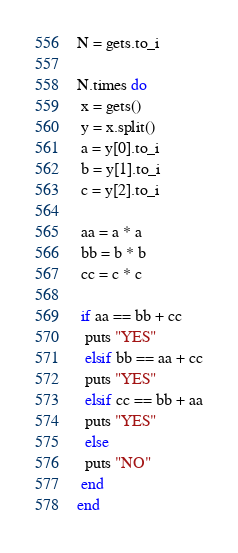<code> <loc_0><loc_0><loc_500><loc_500><_Ruby_>N = gets.to_i

N.times do
 x = gets()
 y = x.split()
 a = y[0].to_i
 b = y[1].to_i
 c = y[2].to_i

 aa = a * a
 bb = b * b
 cc = c * c

 if aa == bb + cc
  puts "YES"
  elsif bb == aa + cc
  puts "YES"
  elsif cc == bb + aa
  puts "YES"
  else
  puts "NO"
 end
end
</code> 